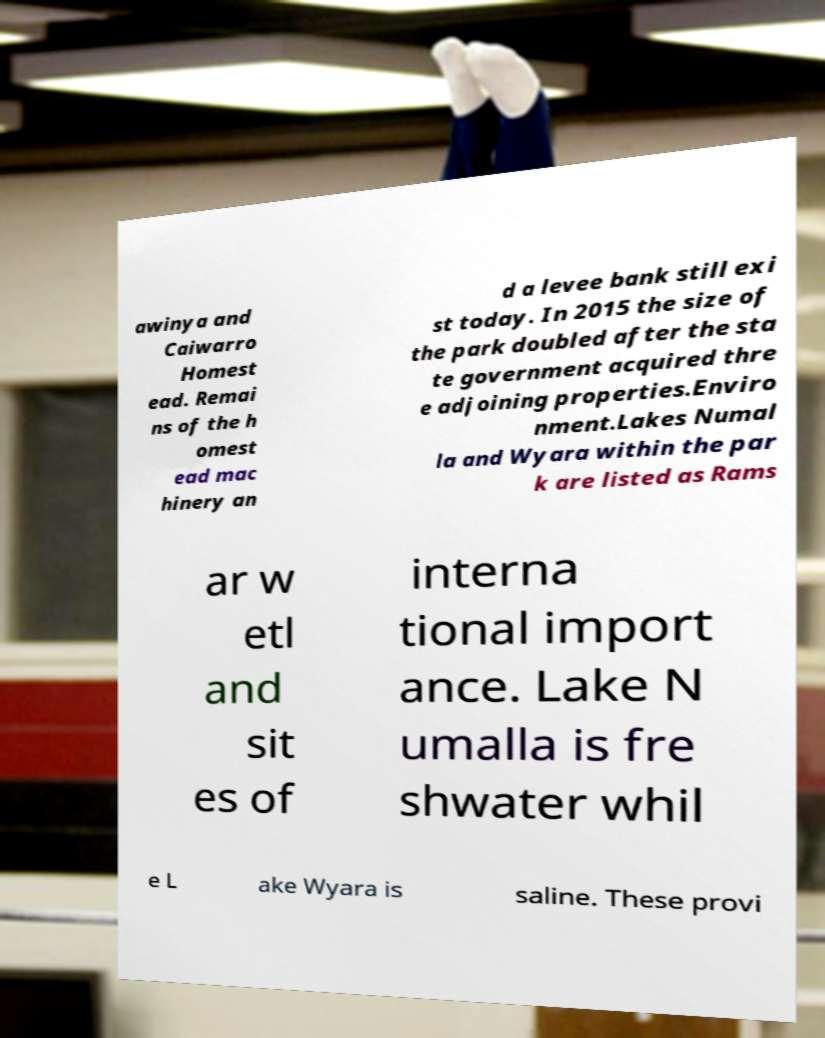What messages or text are displayed in this image? I need them in a readable, typed format. awinya and Caiwarro Homest ead. Remai ns of the h omest ead mac hinery an d a levee bank still exi st today. In 2015 the size of the park doubled after the sta te government acquired thre e adjoining properties.Enviro nment.Lakes Numal la and Wyara within the par k are listed as Rams ar w etl and sit es of interna tional import ance. Lake N umalla is fre shwater whil e L ake Wyara is saline. These provi 